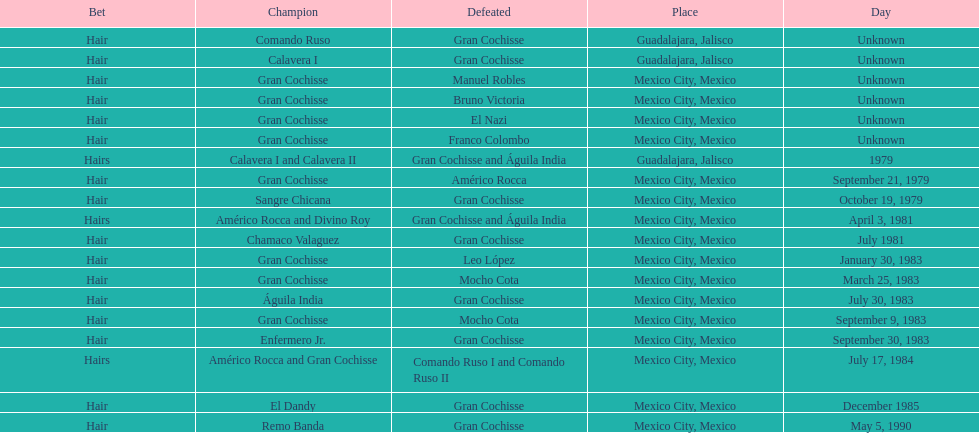How many games more than chamaco valaguez did sangre chicana win? 0. 